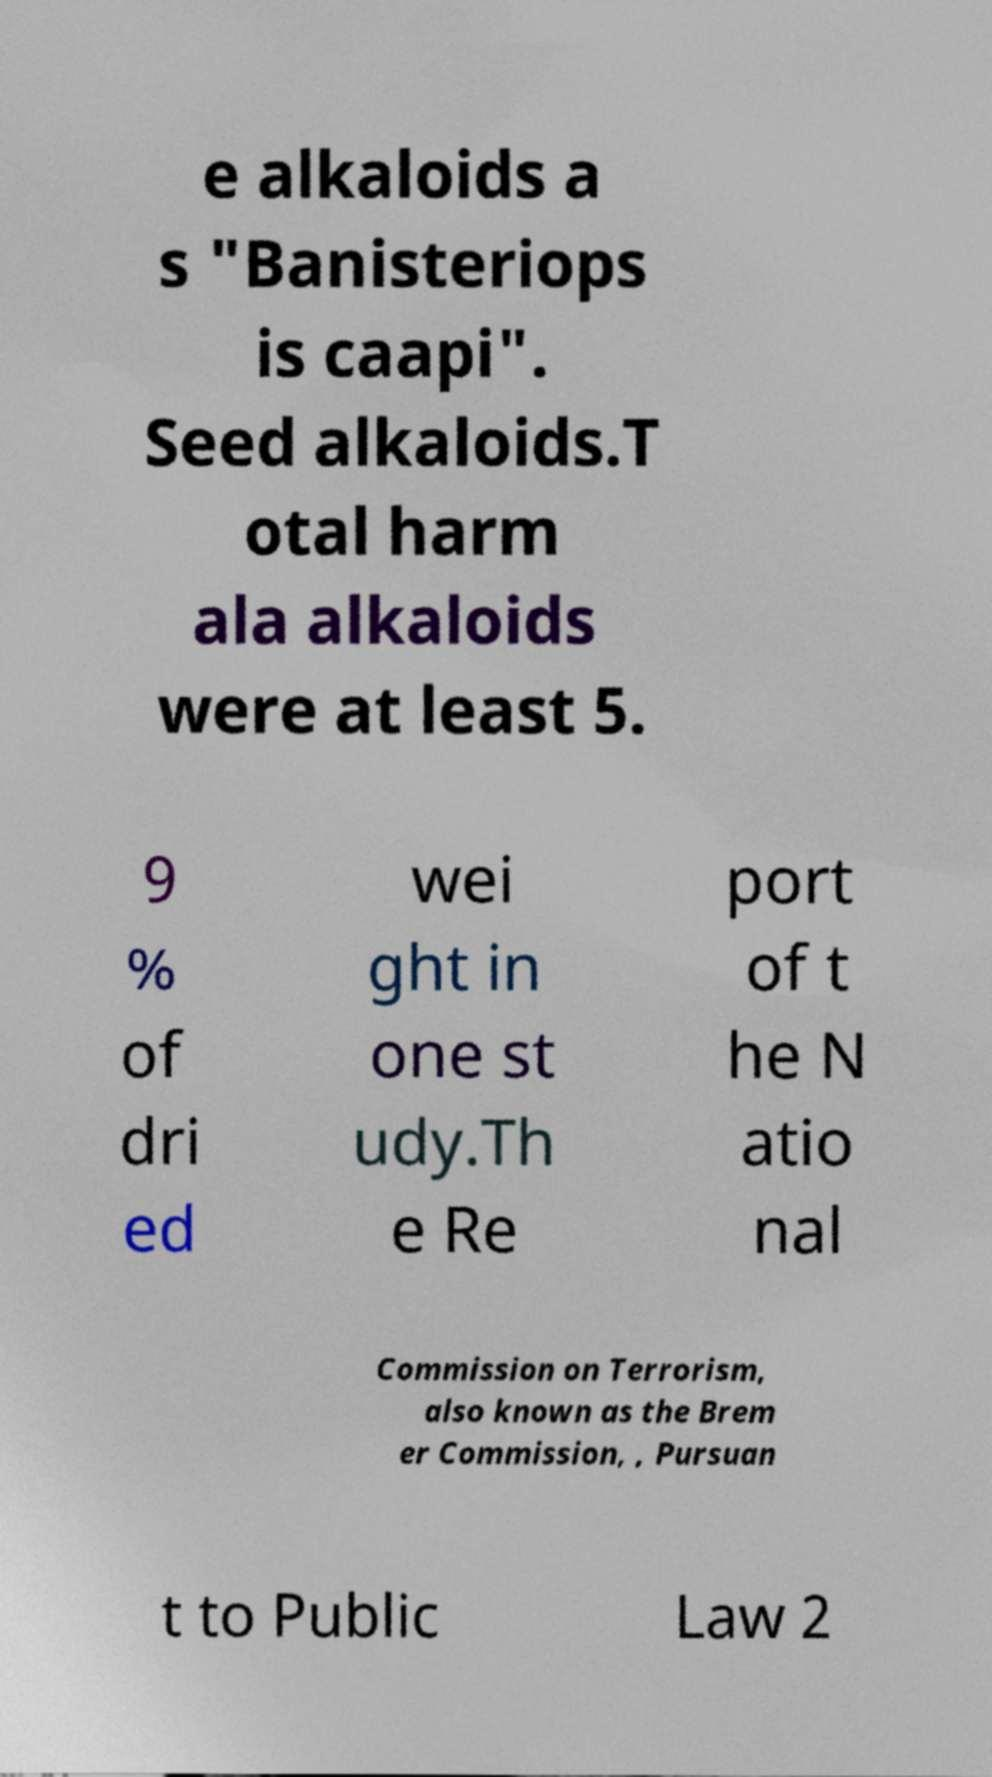Please read and relay the text visible in this image. What does it say? e alkaloids a s "Banisteriops is caapi". Seed alkaloids.T otal harm ala alkaloids were at least 5. 9 % of dri ed wei ght in one st udy.Th e Re port of t he N atio nal Commission on Terrorism, also known as the Brem er Commission, , Pursuan t to Public Law 2 